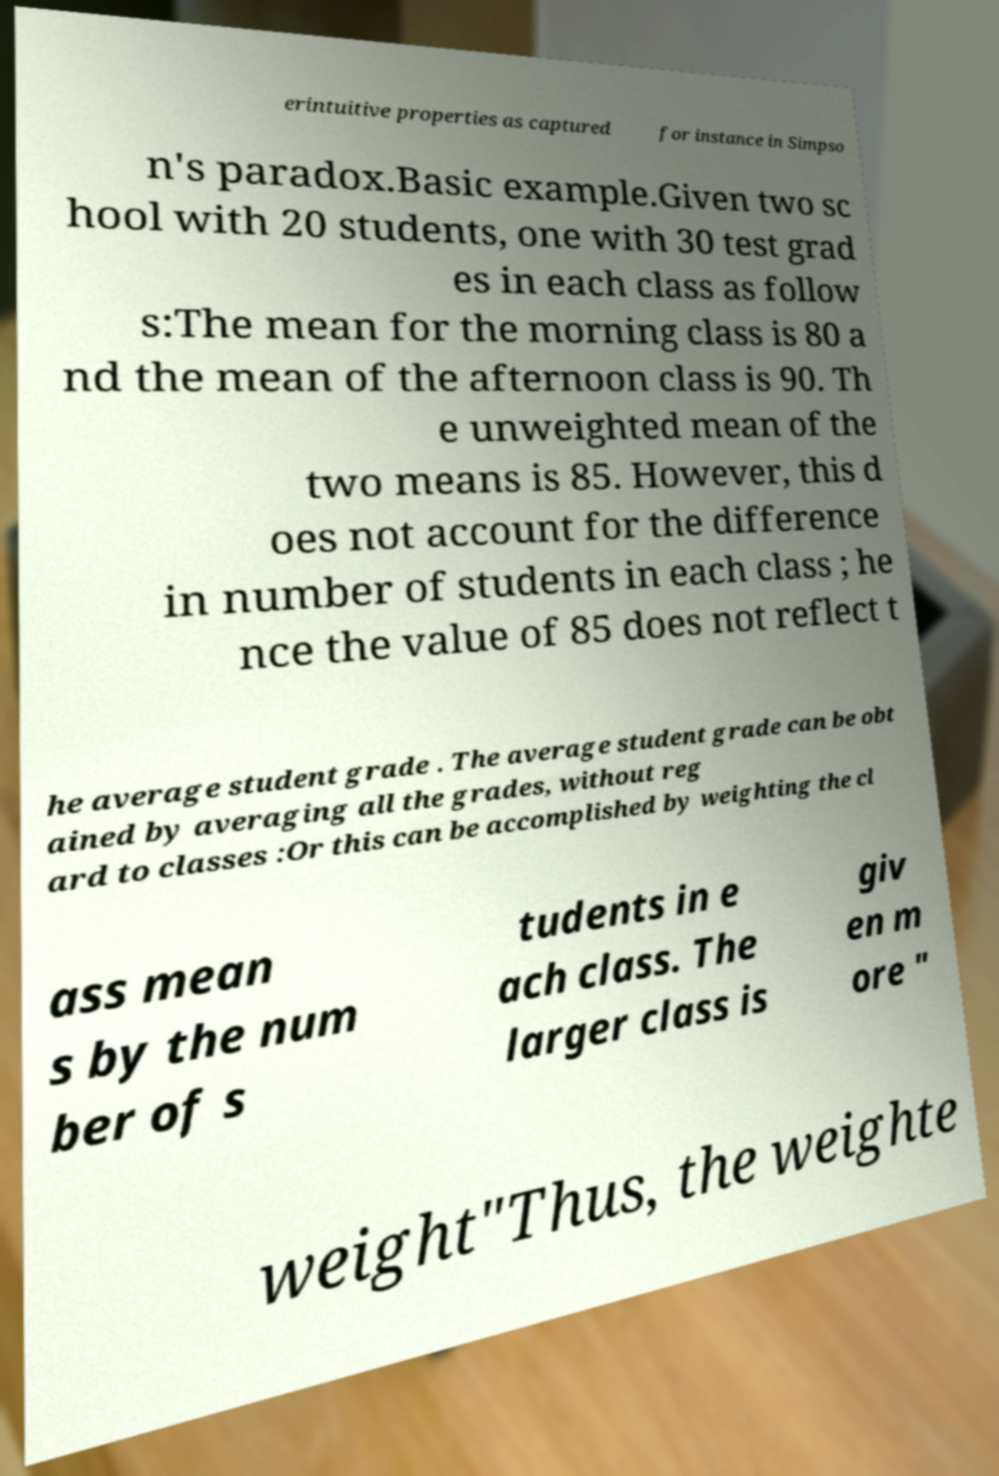Please read and relay the text visible in this image. What does it say? erintuitive properties as captured for instance in Simpso n's paradox.Basic example.Given two sc hool with 20 students, one with 30 test grad es in each class as follow s:The mean for the morning class is 80 a nd the mean of the afternoon class is 90. Th e unweighted mean of the two means is 85. However, this d oes not account for the difference in number of students in each class ; he nce the value of 85 does not reflect t he average student grade . The average student grade can be obt ained by averaging all the grades, without reg ard to classes :Or this can be accomplished by weighting the cl ass mean s by the num ber of s tudents in e ach class. The larger class is giv en m ore " weight"Thus, the weighte 